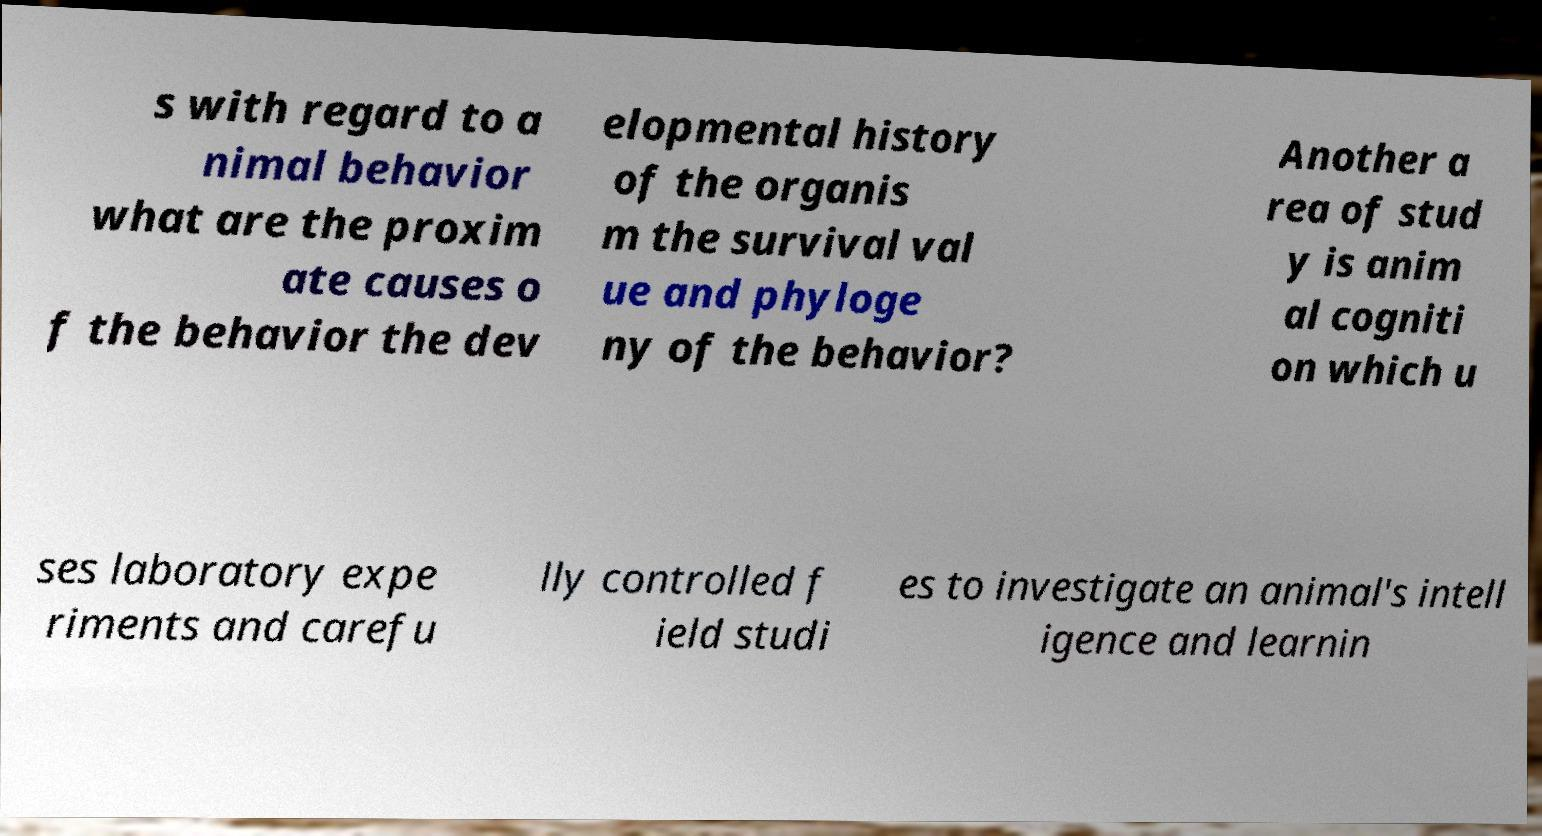I need the written content from this picture converted into text. Can you do that? s with regard to a nimal behavior what are the proxim ate causes o f the behavior the dev elopmental history of the organis m the survival val ue and phyloge ny of the behavior? Another a rea of stud y is anim al cogniti on which u ses laboratory expe riments and carefu lly controlled f ield studi es to investigate an animal's intell igence and learnin 